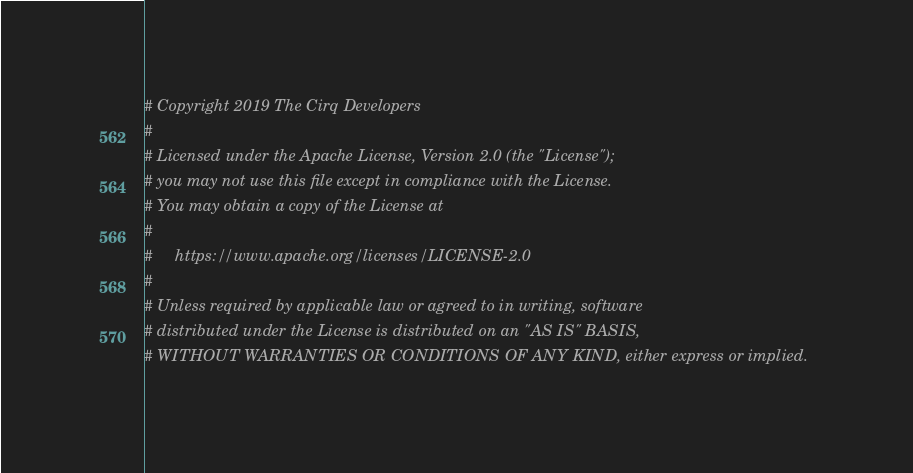Convert code to text. <code><loc_0><loc_0><loc_500><loc_500><_Python_># Copyright 2019 The Cirq Developers
#
# Licensed under the Apache License, Version 2.0 (the "License");
# you may not use this file except in compliance with the License.
# You may obtain a copy of the License at
#
#     https://www.apache.org/licenses/LICENSE-2.0
#
# Unless required by applicable law or agreed to in writing, software
# distributed under the License is distributed on an "AS IS" BASIS,
# WITHOUT WARRANTIES OR CONDITIONS OF ANY KIND, either express or implied.</code> 